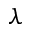<formula> <loc_0><loc_0><loc_500><loc_500>\lambda</formula> 